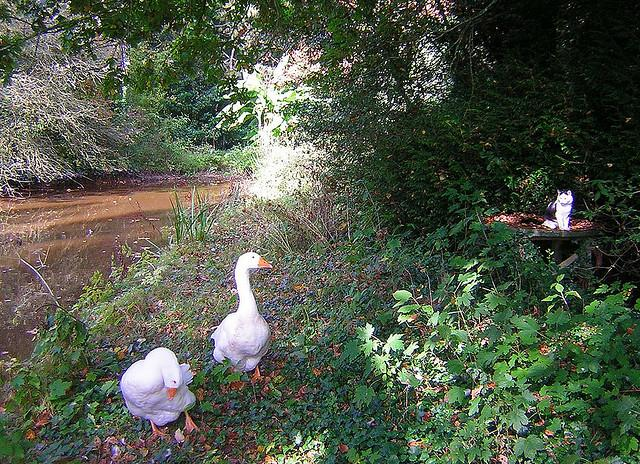Where is the cat staring to? Please explain your reasoning. ducks. The cat is visible in the background and based on its eye line, and known interests, answer a is correct. 